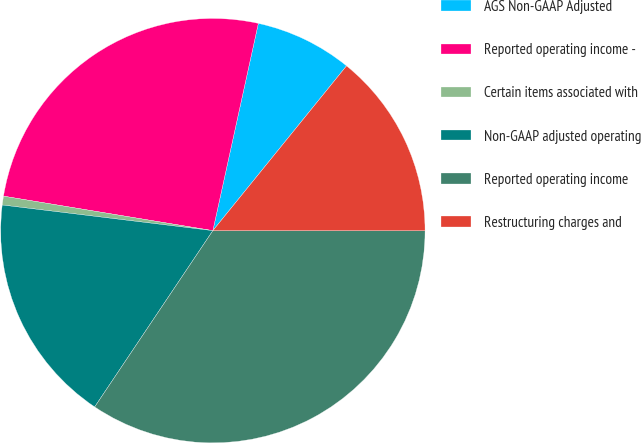Convert chart to OTSL. <chart><loc_0><loc_0><loc_500><loc_500><pie_chart><fcel>AGS Non-GAAP Adjusted<fcel>Reported operating income -<fcel>Certain items associated with<fcel>Non-GAAP adjusted operating<fcel>Reported operating income<fcel>Restructuring charges and<nl><fcel>7.41%<fcel>25.84%<fcel>0.67%<fcel>17.53%<fcel>34.39%<fcel>14.16%<nl></chart> 